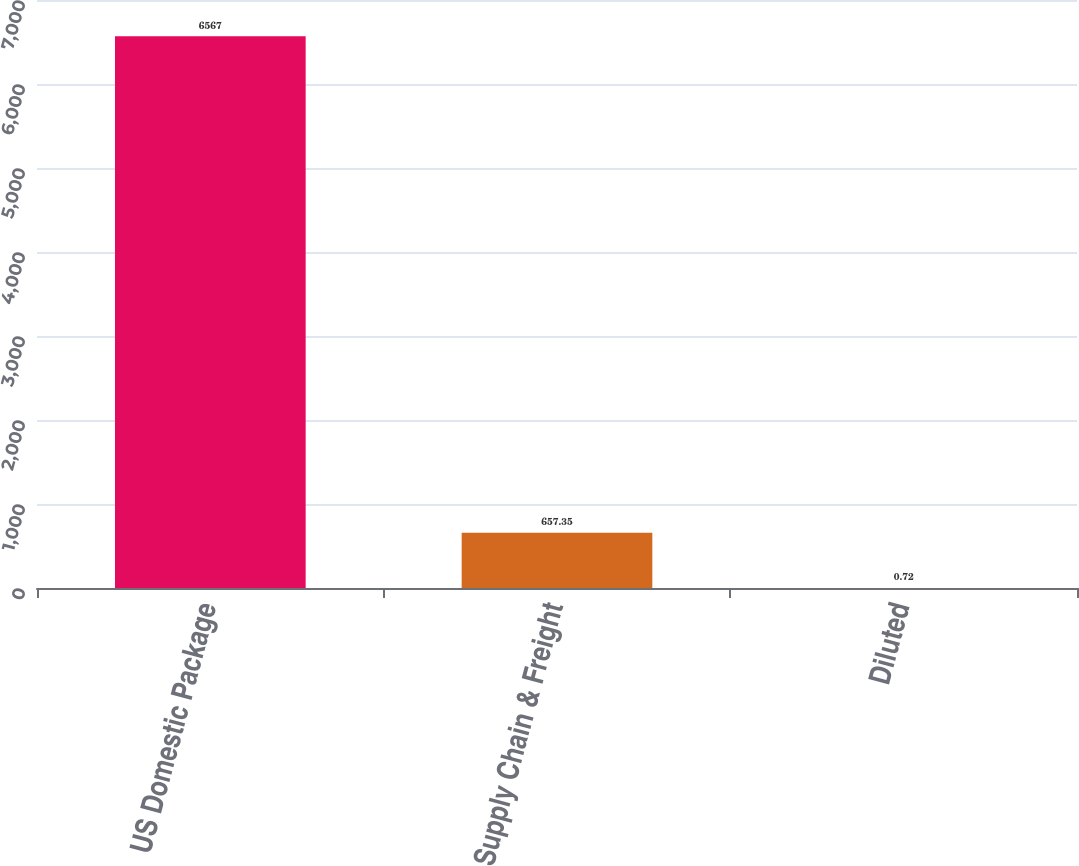<chart> <loc_0><loc_0><loc_500><loc_500><bar_chart><fcel>US Domestic Package<fcel>Supply Chain & Freight<fcel>Diluted<nl><fcel>6567<fcel>657.35<fcel>0.72<nl></chart> 